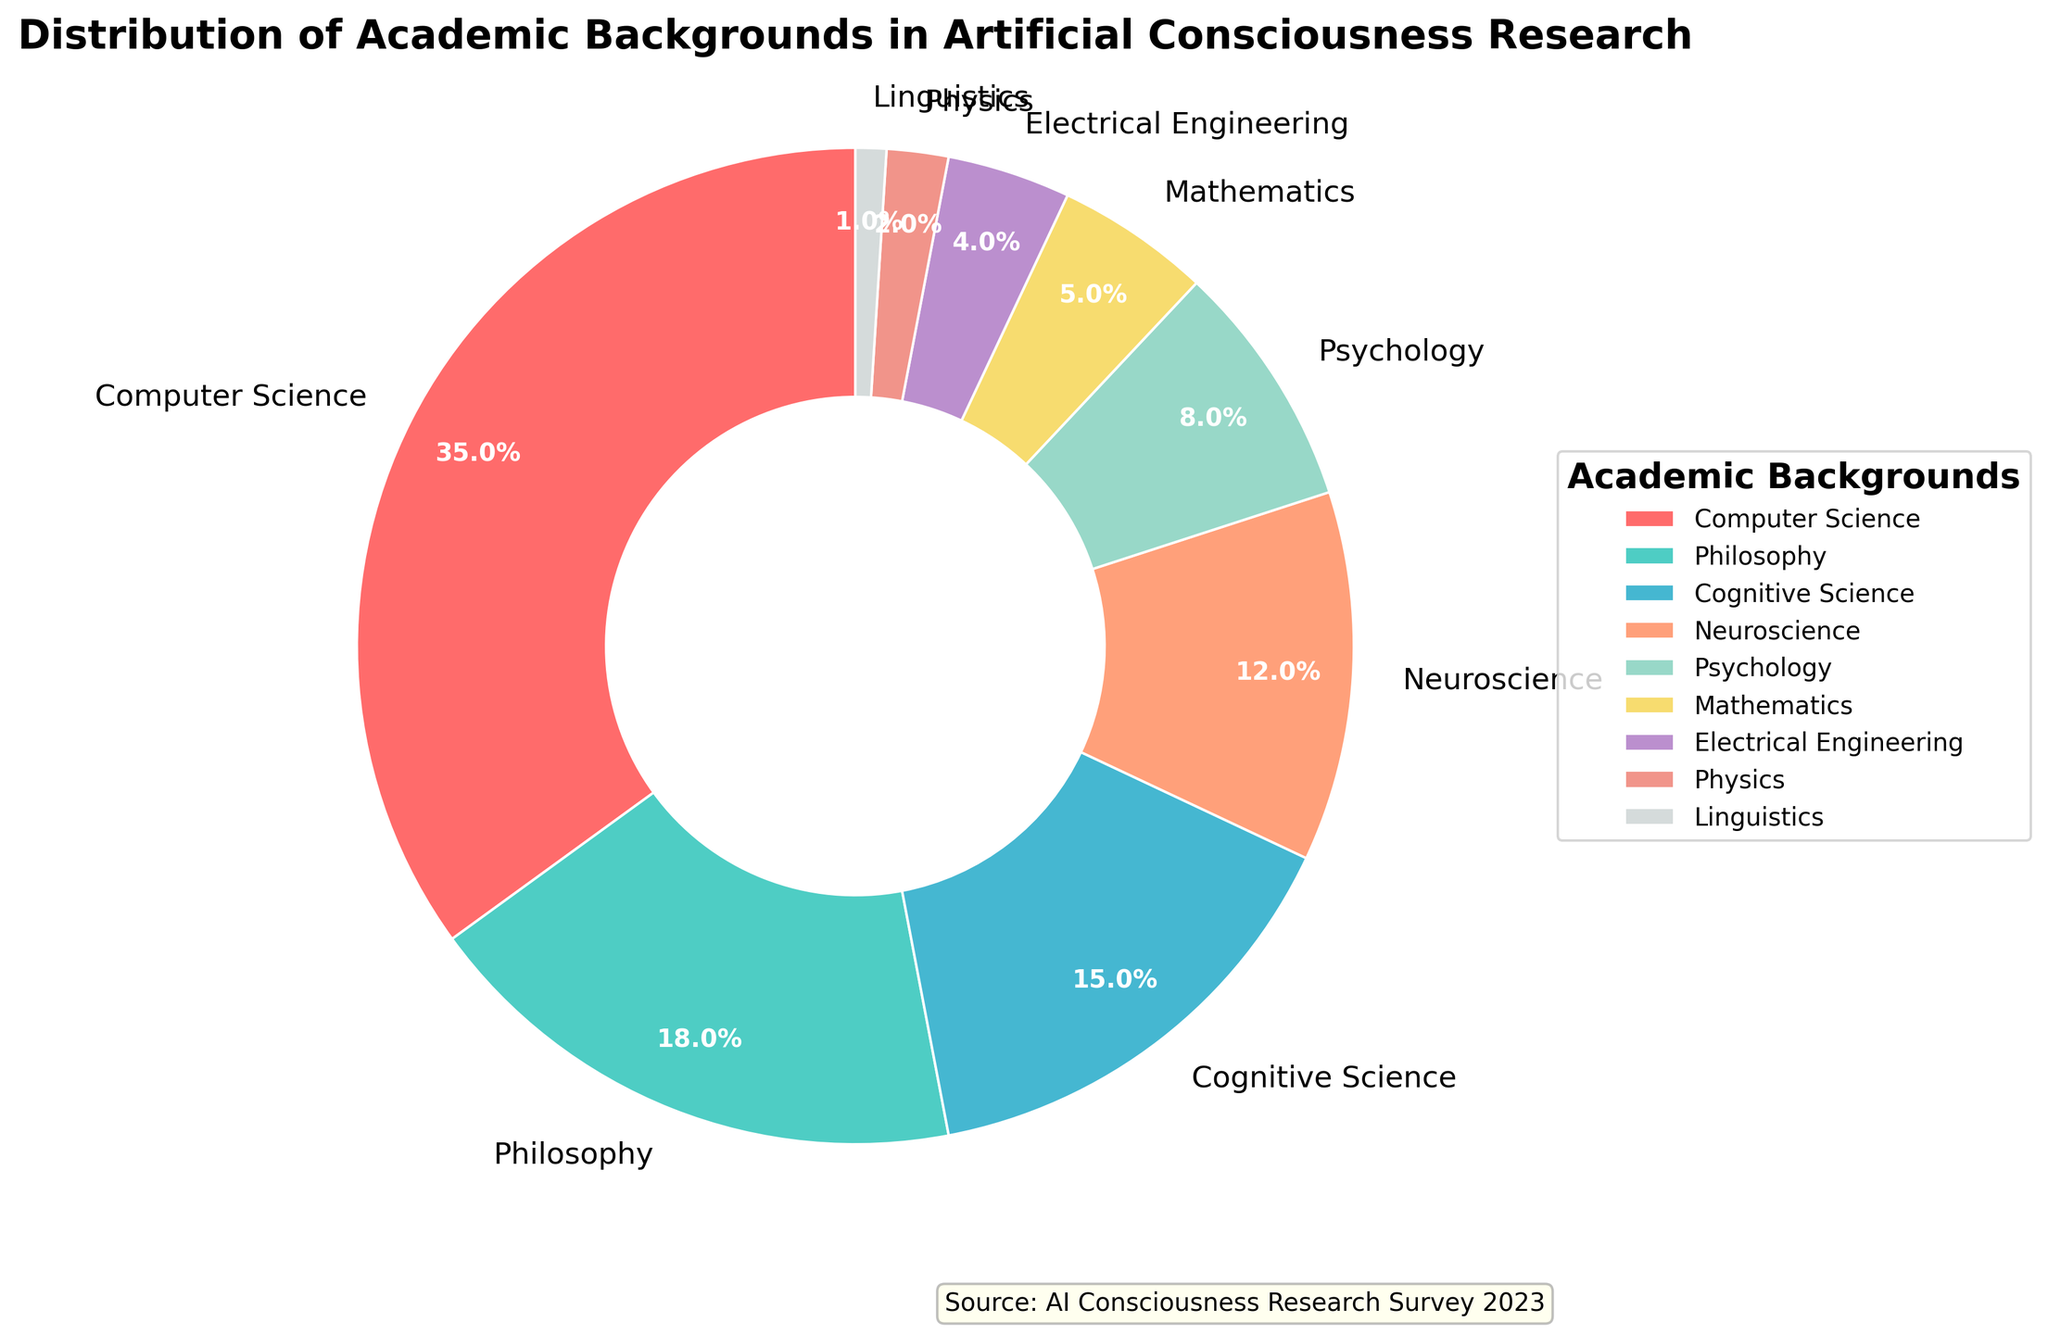What are the three largest academic backgrounds among researchers in the field of artificial consciousness? By looking at the figure's labeled segments, we can see that the three largest segments are Computer Science (35%), Philosophy (18%), and Cognitive Science (15%).
Answer: Computer Science, Philosophy, Cognitive Science Which academic background has the smallest percentage representation in the figure? By looking at the smallest segment in the pie chart, it's clear that Linguistics, with 1%, has the smallest representation.
Answer: Linguistics What is the combined percentage of researchers from Computer Science and Philosophy backgrounds? From the figure, we see that Computer Science is 35% and Philosophy is 18%. By adding these percentages together (35 + 18), we get a combined percentage of 53%.
Answer: 53% Which academic background has a greater percentage, Psychology or Mathematics, and by how much? The figure shows Psychology at 8% and Mathematics at 5%. Subtracting the smaller percentage from the larger (8 - 5), we get 3%. Hence, Psychology has a greater percentage by 3%.
Answer: Psychology by 3% What percentage of researchers have an academic background in either Cognitive Science or Neuroscience? According to the figure, Cognitive Science accounts for 15% and Neuroscience accounts for 12%. Adding these two percentages together (15 + 12), we get 27%.
Answer: 27% How does the percentage of researchers with a Neuroscience background compare to those with a Cognitive Science background? The figure shows Neuroscience at 12% and Cognitive Science at 15%. Since 12 is less than 15, we can conclude that Neuroscience has a lower percentage than Cognitive Science by 3%.
Answer: Neuroscience has 3% less What academic background segment is represented by a green color in the pie chart? By referring to the green colored segment in the figure, we can identify that it corresponds to Cognitive Science, which has a 15% representation.
Answer: Cognitive Science Which academic backgrounds combined account for approximately half of the total representation in the figure? The figure shows that Computer Science is 35% and Philosophy is 18%. Adding these percentages together (35 + 18) gives us 53%, which is just over half of the total representation.
Answer: Computer Science and Philosophy How many academic backgrounds have a representation of 10% or more in the pie chart? By viewing the percentages in the figure, we see that Computer Science (35%), Philosophy (18%), Cognitive Science (15%), and Neuroscience (12%) have representations of 10% or more. This gives us a total of 4 academic backgrounds.
Answer: 4 